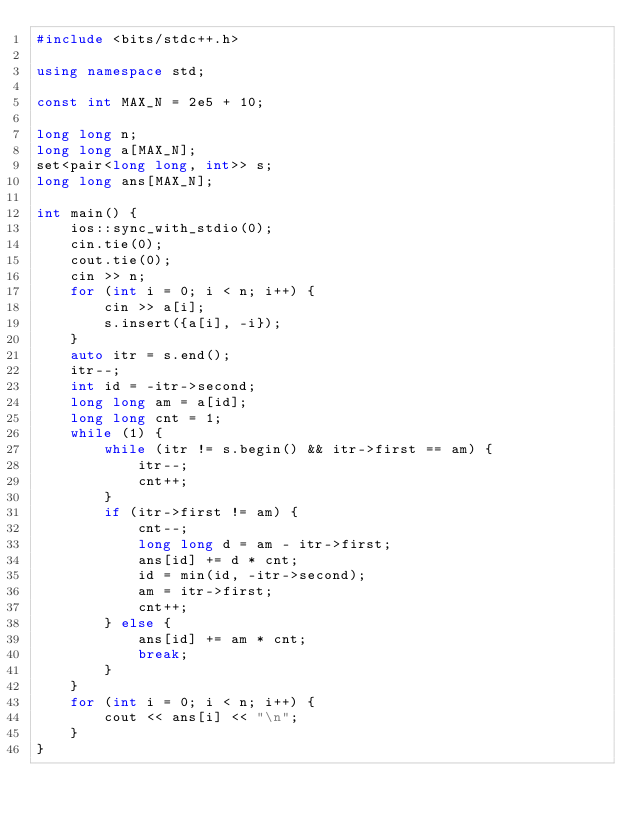Convert code to text. <code><loc_0><loc_0><loc_500><loc_500><_C++_>#include <bits/stdc++.h>

using namespace std;

const int MAX_N = 2e5 + 10;

long long n;
long long a[MAX_N];
set<pair<long long, int>> s;
long long ans[MAX_N];

int main() {
    ios::sync_with_stdio(0);
    cin.tie(0);
    cout.tie(0);
    cin >> n;
    for (int i = 0; i < n; i++) {
        cin >> a[i];
        s.insert({a[i], -i});
    }
    auto itr = s.end();
    itr--;
    int id = -itr->second;
    long long am = a[id];
    long long cnt = 1;
    while (1) {
        while (itr != s.begin() && itr->first == am) {
            itr--;
            cnt++;
        }
        if (itr->first != am) {
            cnt--;
            long long d = am - itr->first;
            ans[id] += d * cnt;
            id = min(id, -itr->second);
            am = itr->first;
            cnt++;
        } else {
            ans[id] += am * cnt;
            break;
        }
    }
    for (int i = 0; i < n; i++) {
        cout << ans[i] << "\n";
    }
}

</code> 